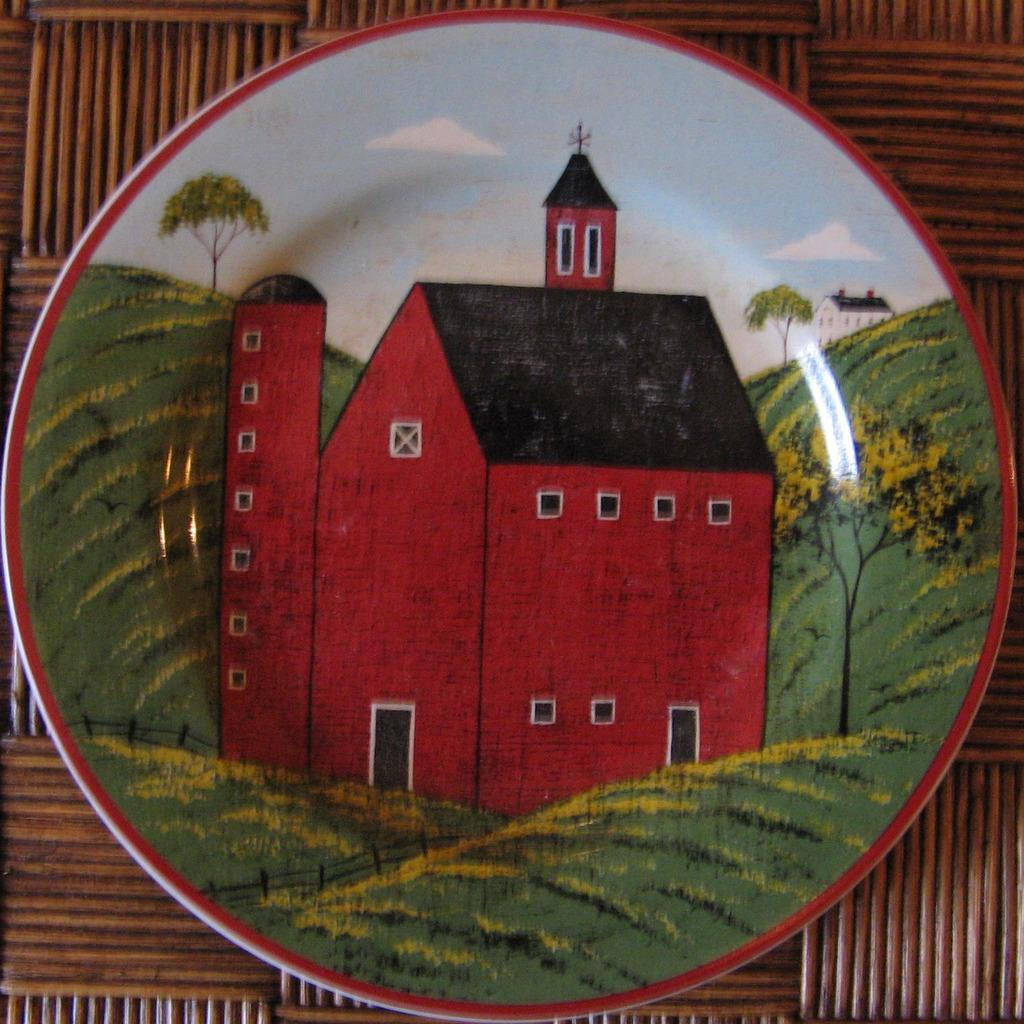What is the main object in the image? There is a table in the image. What is on the table? On the table, there is a plate. What is depicted on the plate? The plate contains a representation of a house, trees, a fence, and grass. Who is the expert on the flowers in the image? There are no flowers present in the image, so there is no expert on them. 